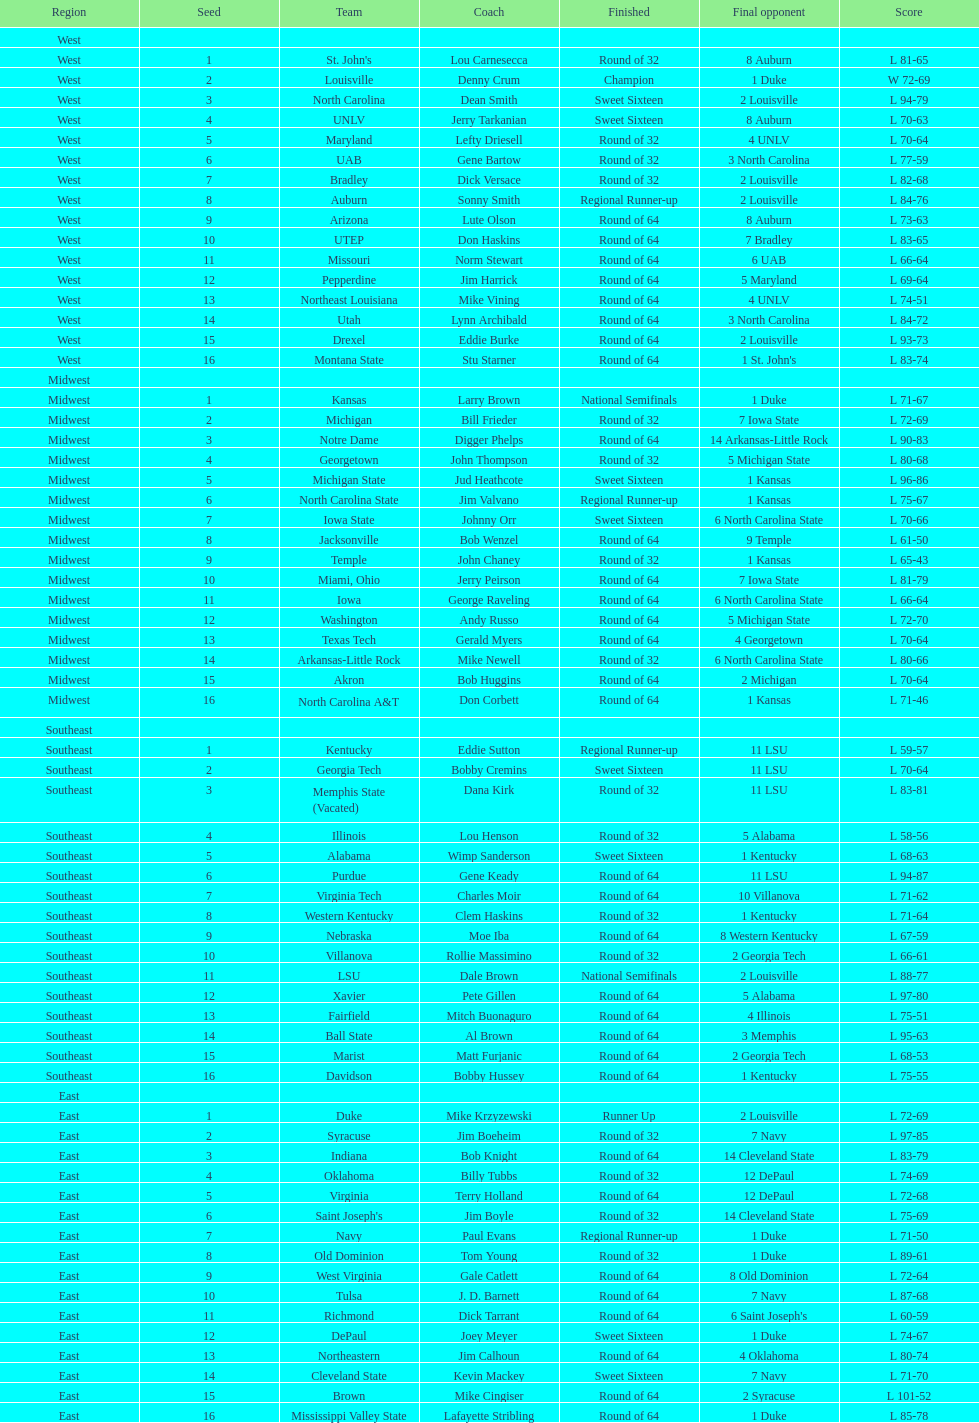What is the quantity of 1 seeds present? 4. 